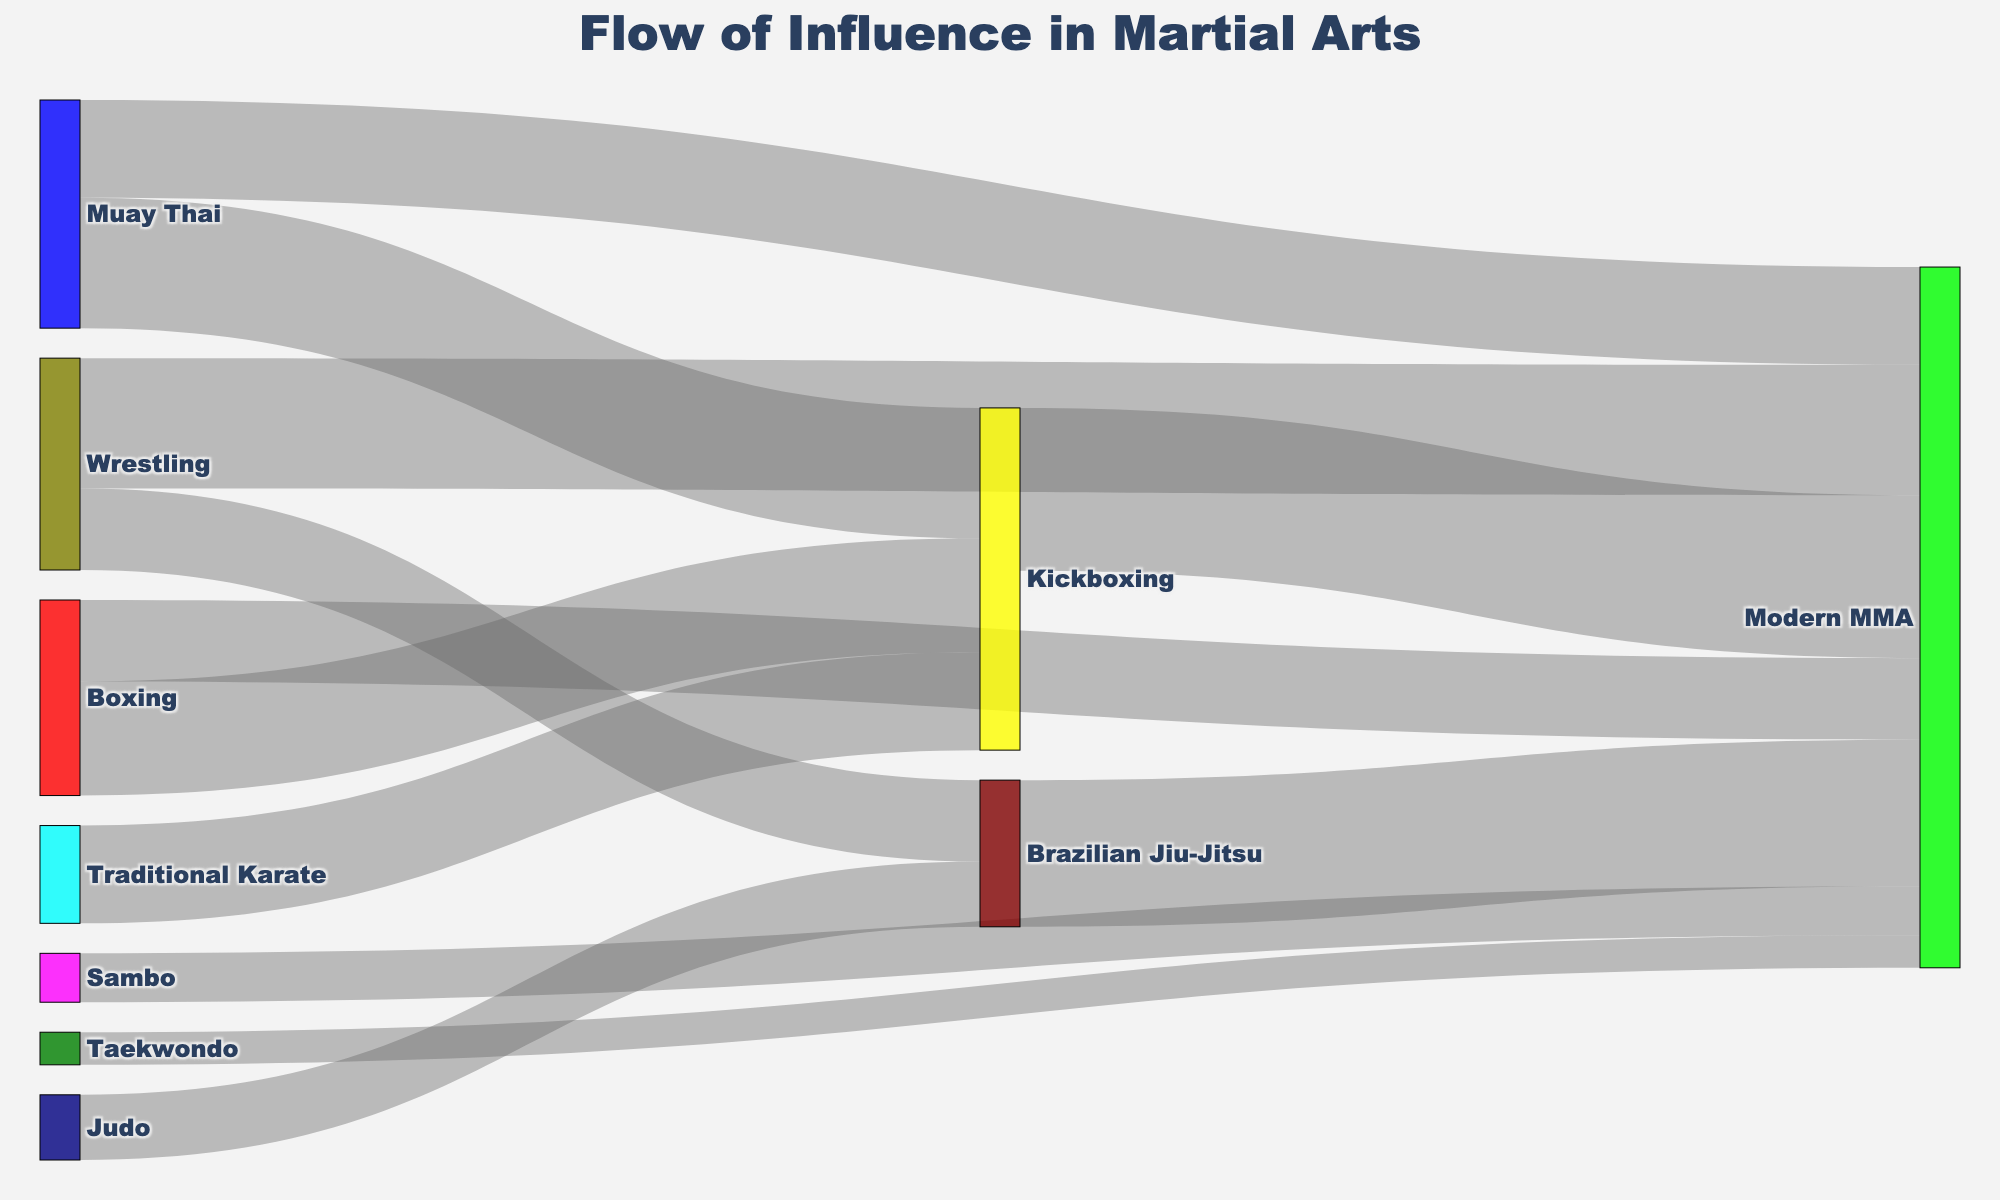what martial art contributes the most influence to Kickboxing? The widest link flowing into "Kickboxing" represents the highest contribution. From the figure, Muay Thai contributes the largest value of 40.
Answer: Muay Thai What is the total influence coming into Modern MMA? Add all the incoming values flowing into "Modern MMA". According to the figure, the values are 50 (Kickboxing) + 45 (Brazilian Jiu-Jitsu) + 15 (Sambo) + 40 (Wrestling) + 10 (Taekwondo) + 30 (Muay Thai) + 25 (Boxing). Thus, the total is 50 + 45 + 15 + 40 + 10 + 30 + 25 = 215.
Answer: 215 How much influence does Wrestling have on both Brazilian Jiu-Jitsu and Modern MMA combined? Sum the values flowing from "Wrestling" to its targets. The values are 25 (to Brazilian Jiu-Jitsu) + 40 (to Modern MMA) = 25 + 40 = 65.
Answer: 65 Is the influence of Brazilian Jiu-Jitsu on Modern MMA greater than Muay Thai? Compare the values from Brazilian Jiu-Jitsu and Muay Thai to Modern MMA. Brazilian Jiu-Jitsu's value is 45, and Muay Thai's value is 30. 45 is greater than 30.
Answer: Yes Which martial art influences Modern MMA more: Taekwondo or Sambo? Compare the influence values from Taekwondo and Sambo to Modern MMA. Taekwondo contributes 10, while Sambo contributes 15. 15 is greater than 10.
Answer: Sambo Which flow has the smallest contribution to Modern MMA? Look for the thinnest link flowing into "Modern MMA". Taekwondo to Modern MMA, with value 10, is the smallest.
Answer: Taekwondo What is the combined influence of Judo and Wrestling on Brazilian Jiu-Jitsu? Sum the contributions of Judo and Wrestling to Brazilian Jiu-Jitsu. Judo contributes 20, and Wrestling contributes 25. Thus, the combined influence is 20 + 25 = 45.
Answer: 45 How does the influence of Boxing on Kickboxing compare to its influence on Modern MMA? Compare the contribution values of Boxing to Kickboxing (35) and Modern MMA (25). 35 is greater than 25.
Answer: Boxing has more influence on Kickboxing Among the martial arts influencing Kickboxing, which has the least impact? Identify the lowest value among the influences on Kickboxing. Traditional Karate contributes 30, Muay Thai 40, and Boxing 35. The lowest is Traditional Karate with 30.
Answer: Traditional Karate 